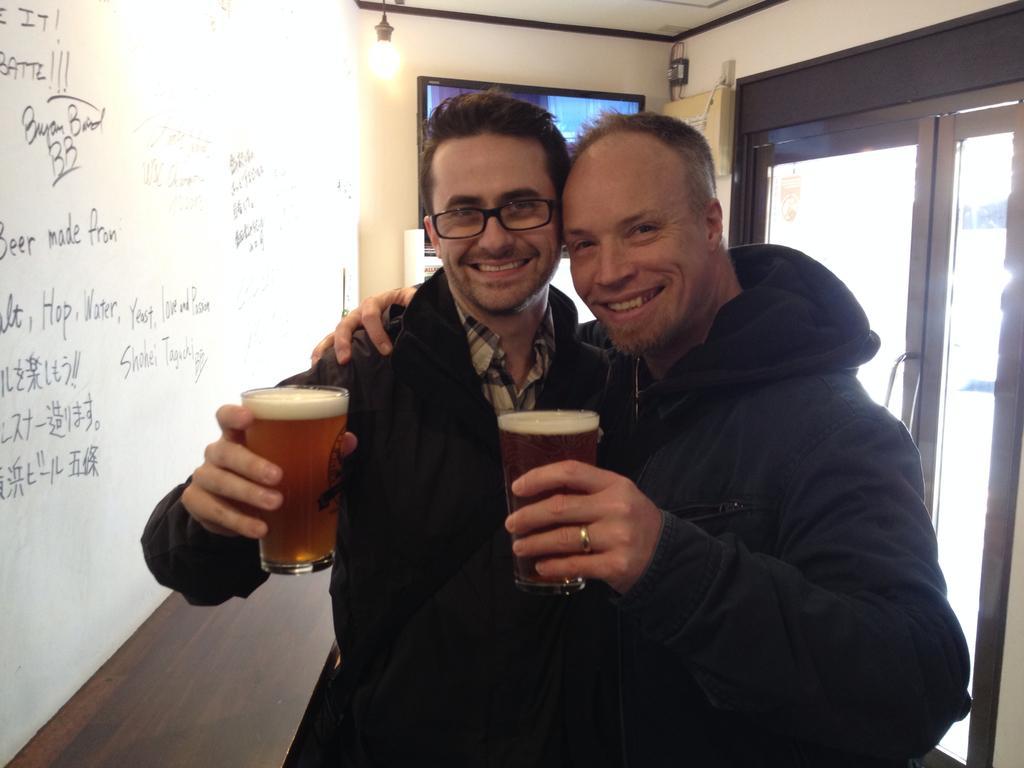How would you summarize this image in a sentence or two? The image is clicked inside the house. There are two men in the image, they are holding glass of beers in their hands. Both are smiling and wearing black color jackets. In the background there is a wall, something written on the wall. To the right there is a door. 